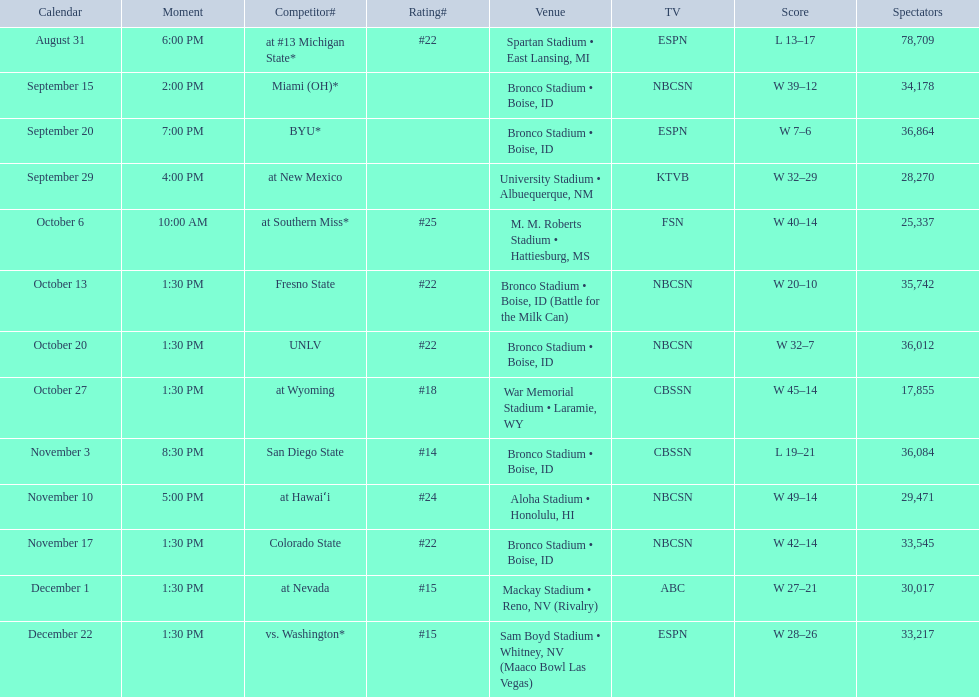What was the most consecutive wins for the team shown in the season? 7. 